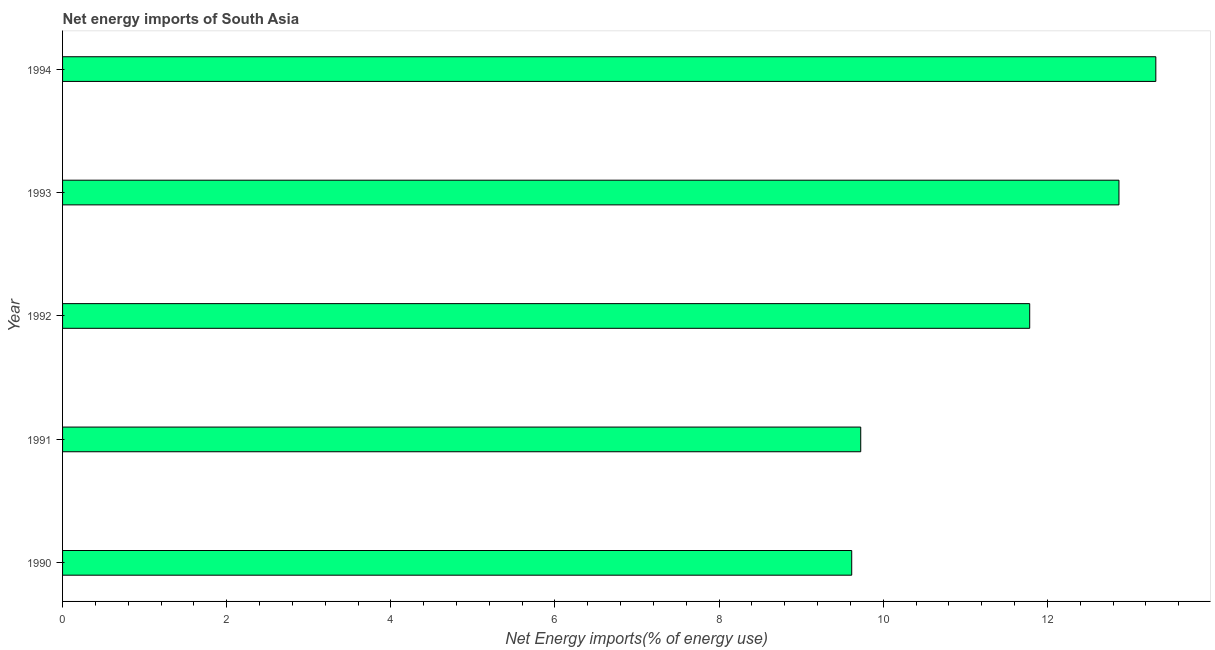Does the graph contain any zero values?
Provide a short and direct response. No. What is the title of the graph?
Provide a succinct answer. Net energy imports of South Asia. What is the label or title of the X-axis?
Give a very brief answer. Net Energy imports(% of energy use). What is the label or title of the Y-axis?
Keep it short and to the point. Year. What is the energy imports in 1993?
Provide a short and direct response. 12.87. Across all years, what is the maximum energy imports?
Give a very brief answer. 13.32. Across all years, what is the minimum energy imports?
Provide a short and direct response. 9.62. What is the sum of the energy imports?
Give a very brief answer. 57.32. What is the difference between the energy imports in 1991 and 1994?
Make the answer very short. -3.6. What is the average energy imports per year?
Ensure brevity in your answer.  11.46. What is the median energy imports?
Offer a very short reply. 11.78. In how many years, is the energy imports greater than 9.2 %?
Offer a very short reply. 5. Do a majority of the years between 1993 and 1992 (inclusive) have energy imports greater than 13.2 %?
Give a very brief answer. No. What is the ratio of the energy imports in 1991 to that in 1994?
Offer a terse response. 0.73. What is the difference between the highest and the second highest energy imports?
Give a very brief answer. 0.45. Is the sum of the energy imports in 1990 and 1994 greater than the maximum energy imports across all years?
Give a very brief answer. Yes. What is the difference between the highest and the lowest energy imports?
Make the answer very short. 3.71. In how many years, is the energy imports greater than the average energy imports taken over all years?
Ensure brevity in your answer.  3. How many bars are there?
Your response must be concise. 5. Are all the bars in the graph horizontal?
Your answer should be compact. Yes. How many years are there in the graph?
Keep it short and to the point. 5. What is the Net Energy imports(% of energy use) of 1990?
Your answer should be compact. 9.62. What is the Net Energy imports(% of energy use) of 1991?
Provide a succinct answer. 9.73. What is the Net Energy imports(% of energy use) in 1992?
Offer a terse response. 11.78. What is the Net Energy imports(% of energy use) in 1993?
Keep it short and to the point. 12.87. What is the Net Energy imports(% of energy use) of 1994?
Make the answer very short. 13.32. What is the difference between the Net Energy imports(% of energy use) in 1990 and 1991?
Provide a succinct answer. -0.11. What is the difference between the Net Energy imports(% of energy use) in 1990 and 1992?
Provide a succinct answer. -2.17. What is the difference between the Net Energy imports(% of energy use) in 1990 and 1993?
Ensure brevity in your answer.  -3.26. What is the difference between the Net Energy imports(% of energy use) in 1990 and 1994?
Give a very brief answer. -3.71. What is the difference between the Net Energy imports(% of energy use) in 1991 and 1992?
Offer a very short reply. -2.06. What is the difference between the Net Energy imports(% of energy use) in 1991 and 1993?
Ensure brevity in your answer.  -3.15. What is the difference between the Net Energy imports(% of energy use) in 1991 and 1994?
Provide a short and direct response. -3.6. What is the difference between the Net Energy imports(% of energy use) in 1992 and 1993?
Your response must be concise. -1.09. What is the difference between the Net Energy imports(% of energy use) in 1992 and 1994?
Provide a short and direct response. -1.54. What is the difference between the Net Energy imports(% of energy use) in 1993 and 1994?
Keep it short and to the point. -0.45. What is the ratio of the Net Energy imports(% of energy use) in 1990 to that in 1992?
Provide a succinct answer. 0.82. What is the ratio of the Net Energy imports(% of energy use) in 1990 to that in 1993?
Offer a terse response. 0.75. What is the ratio of the Net Energy imports(% of energy use) in 1990 to that in 1994?
Offer a very short reply. 0.72. What is the ratio of the Net Energy imports(% of energy use) in 1991 to that in 1992?
Your answer should be very brief. 0.82. What is the ratio of the Net Energy imports(% of energy use) in 1991 to that in 1993?
Your answer should be very brief. 0.76. What is the ratio of the Net Energy imports(% of energy use) in 1991 to that in 1994?
Your response must be concise. 0.73. What is the ratio of the Net Energy imports(% of energy use) in 1992 to that in 1993?
Provide a short and direct response. 0.92. What is the ratio of the Net Energy imports(% of energy use) in 1992 to that in 1994?
Make the answer very short. 0.89. 